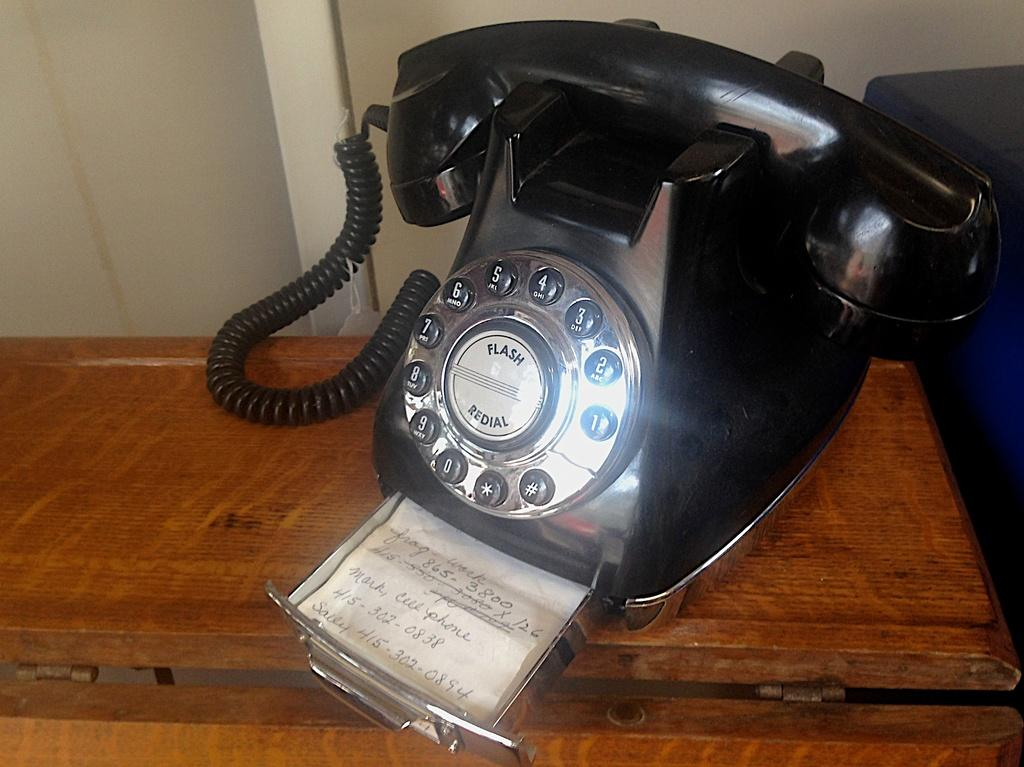What type of telephone is in the image? There is an old black telephone in the image. Where is the telephone placed? The telephone is placed on a wooden table top. What color is the wall visible in the background of the image? The wall visible in the background of the image is yellow. How many plantations are visible in the image? There are no plantations visible in the image; it features an old black telephone on a wooden table top with a yellow wall in the background. What type of tax is being discussed in the image? There is no discussion of tax in the image; it only shows an old black telephone, a wooden table top, and a yellow wall. 